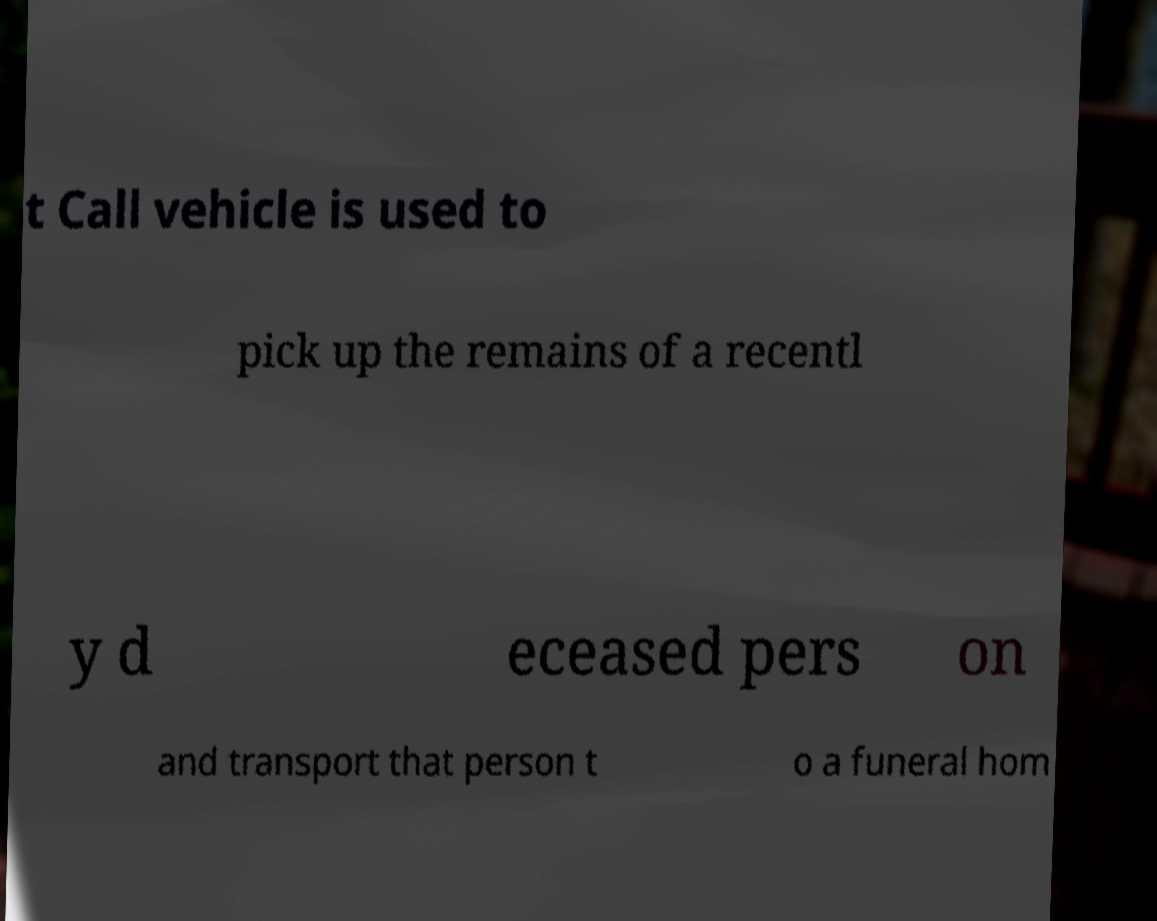Can you read and provide the text displayed in the image?This photo seems to have some interesting text. Can you extract and type it out for me? t Call vehicle is used to pick up the remains of a recentl y d eceased pers on and transport that person t o a funeral hom 